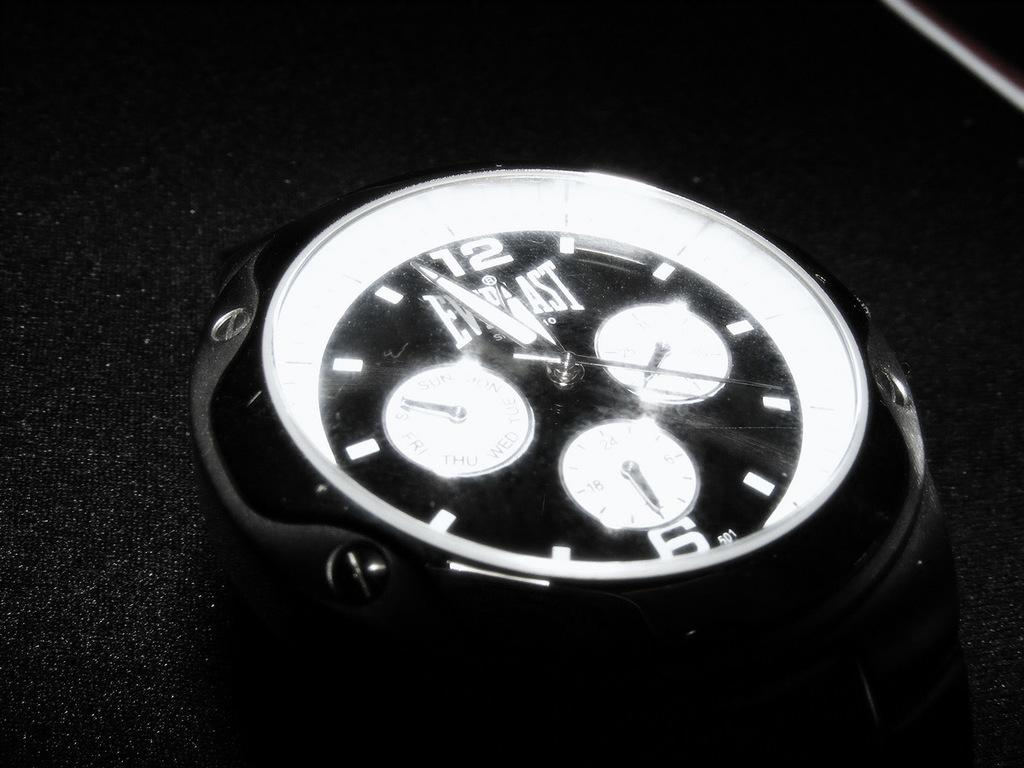<image>
Relay a brief, clear account of the picture shown. An Everlast clock has white dials and a black background. 